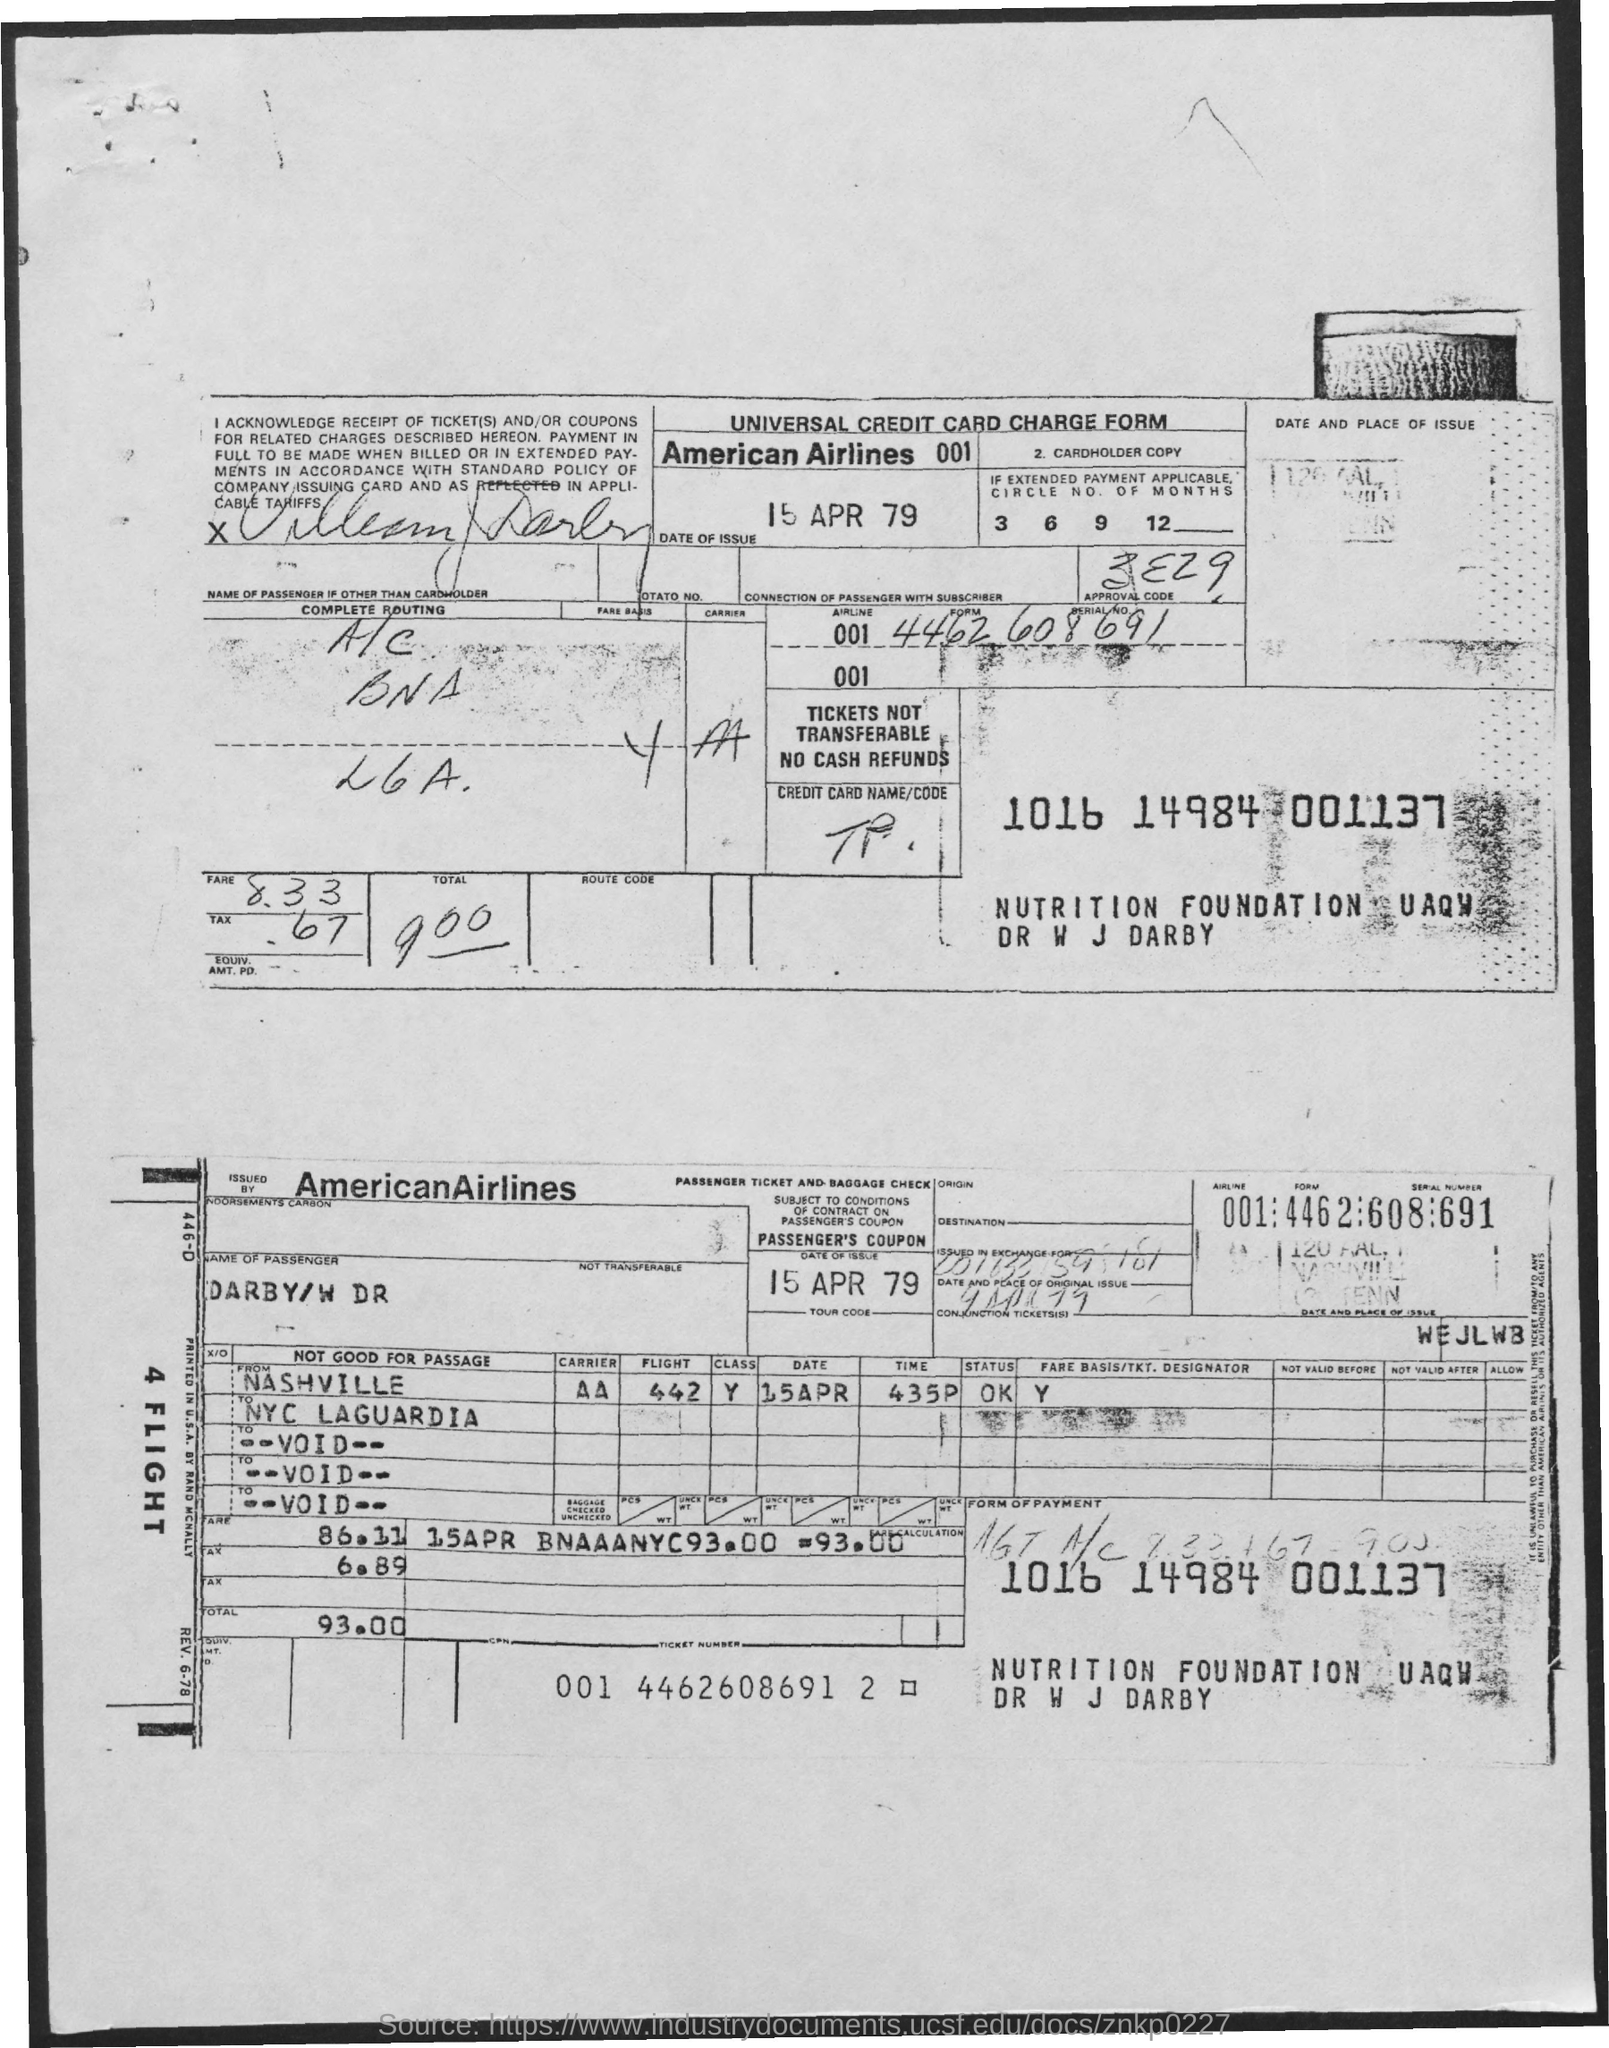What is this form on?
Your answer should be very brief. Universal credit card charge form. Which airlines does this form belongs to?
Keep it short and to the point. American airlines. What is the date of issue of the form?
Keep it short and to the point. 15 apr 79. 